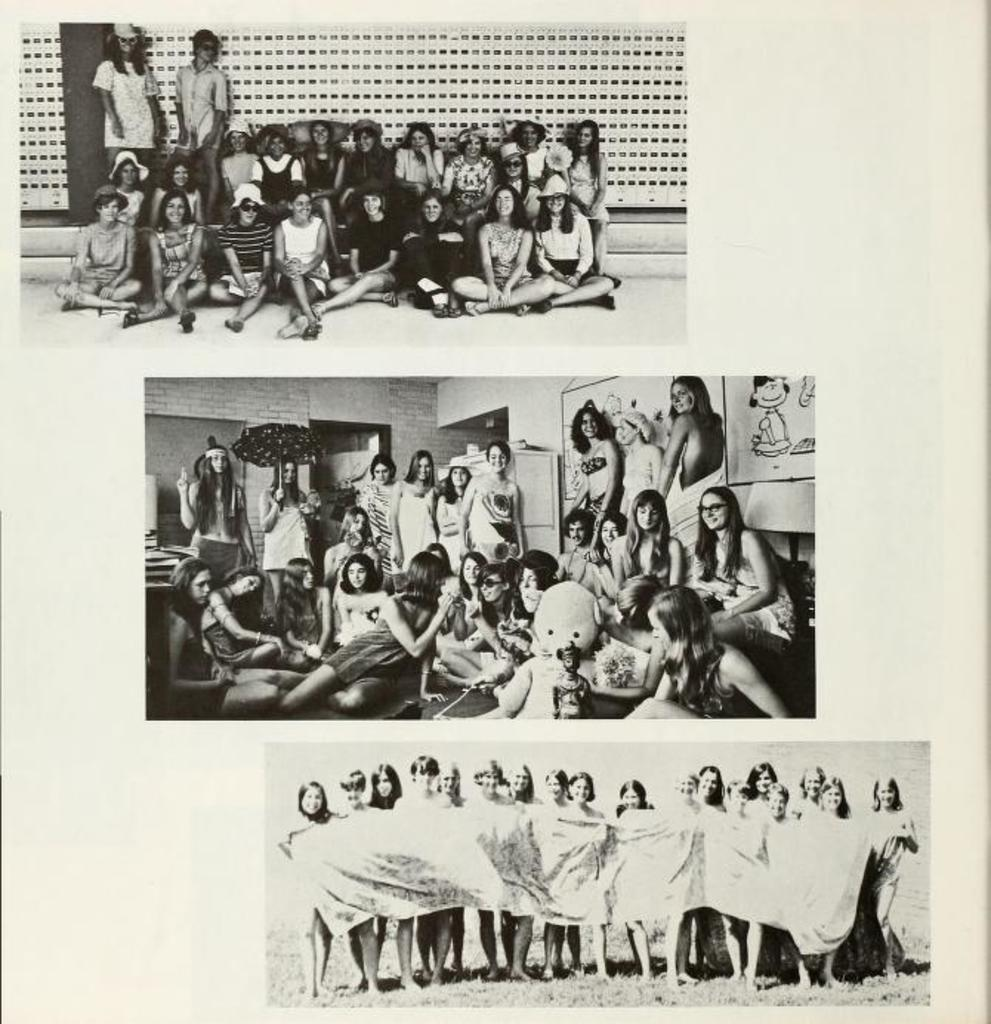What is featured on the poster in the image? There is a poster with three pictures in the image. What can be seen in the pictures on the poster? In the pictures, there are people, an umbrella, a couch, posters, and some people holding a blanket. Can you describe the setting of one of the pictures? In one picture, there is a couch and people holding a blanket. What type of jam is being spread on the wood in the image? There is no jam or wood present in the image; it features a poster with pictures of people and objects. 